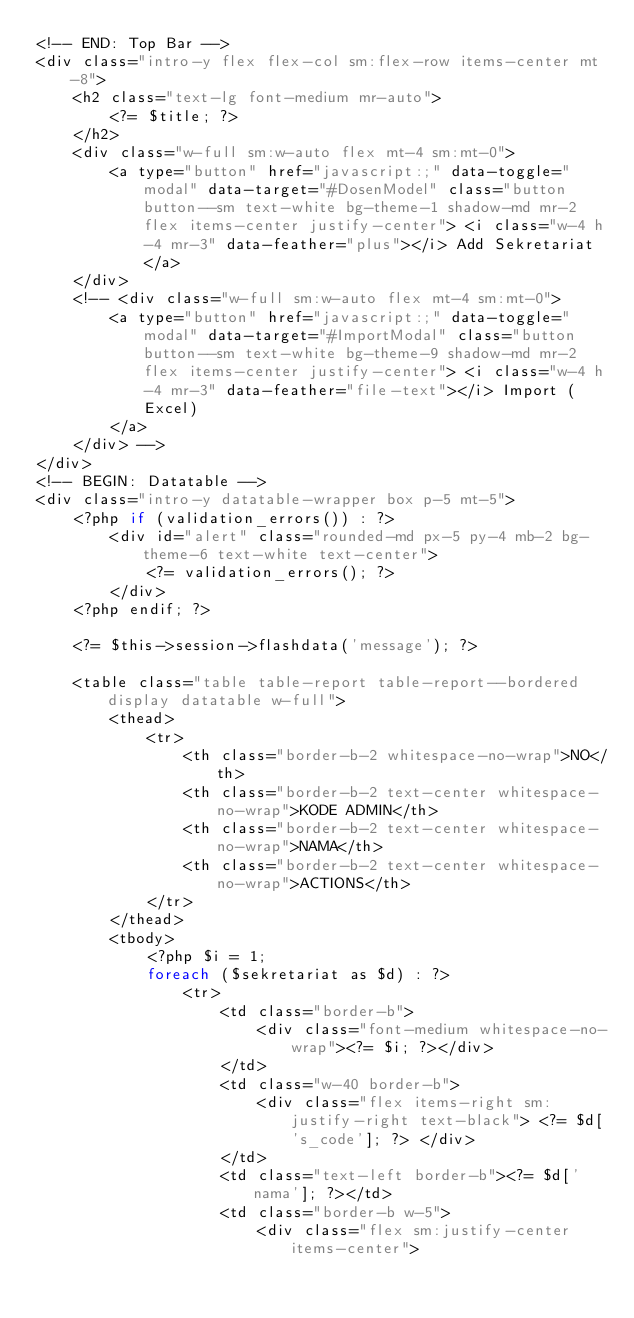Convert code to text. <code><loc_0><loc_0><loc_500><loc_500><_PHP_><!-- END: Top Bar -->
<div class="intro-y flex flex-col sm:flex-row items-center mt-8">
    <h2 class="text-lg font-medium mr-auto">
        <?= $title; ?>
    </h2>
    <div class="w-full sm:w-auto flex mt-4 sm:mt-0">
        <a type="button" href="javascript:;" data-toggle="modal" data-target="#DosenModel" class="button button--sm text-white bg-theme-1 shadow-md mr-2 flex items-center justify-center"> <i class="w-4 h-4 mr-3" data-feather="plus"></i> Add Sekretariat </a>
    </div>
    <!-- <div class="w-full sm:w-auto flex mt-4 sm:mt-0">
        <a type="button" href="javascript:;" data-toggle="modal" data-target="#ImportModal" class="button button--sm text-white bg-theme-9 shadow-md mr-2 flex items-center justify-center"> <i class="w-4 h-4 mr-3" data-feather="file-text"></i> Import (Excel)
        </a>
    </div> -->
</div>
<!-- BEGIN: Datatable -->
<div class="intro-y datatable-wrapper box p-5 mt-5">
    <?php if (validation_errors()) : ?>
        <div id="alert" class="rounded-md px-5 py-4 mb-2 bg-theme-6 text-white text-center">
            <?= validation_errors(); ?>
        </div>
    <?php endif; ?>

    <?= $this->session->flashdata('message'); ?>

    <table class="table table-report table-report--bordered display datatable w-full">
        <thead>
            <tr>
                <th class="border-b-2 whitespace-no-wrap">NO</th>
                <th class="border-b-2 text-center whitespace-no-wrap">KODE ADMIN</th>
                <th class="border-b-2 text-center whitespace-no-wrap">NAMA</th>
                <th class="border-b-2 text-center whitespace-no-wrap">ACTIONS</th>
            </tr>
        </thead>
        <tbody>
            <?php $i = 1;
            foreach ($sekretariat as $d) : ?>
                <tr>
                    <td class="border-b">
                        <div class="font-medium whitespace-no-wrap"><?= $i; ?></div>
                    </td>
                    <td class="w-40 border-b">
                        <div class="flex items-right sm:justify-right text-black"> <?= $d['s_code']; ?> </div>
                    </td>
                    <td class="text-left border-b"><?= $d['nama']; ?></td>
                    <td class="border-b w-5">
                        <div class="flex sm:justify-center items-center"></code> 